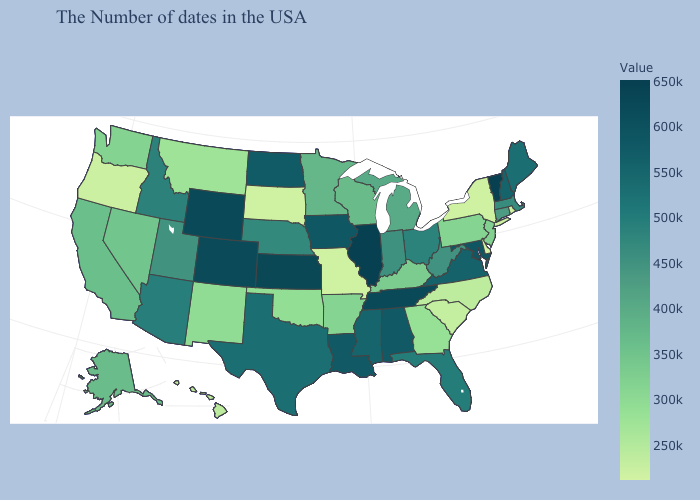Does Illinois have the highest value in the MidWest?
Give a very brief answer. Yes. Among the states that border Connecticut , does New York have the lowest value?
Concise answer only. Yes. Among the states that border Michigan , does Ohio have the highest value?
Concise answer only. Yes. Among the states that border Maryland , which have the lowest value?
Write a very short answer. Delaware. Does Maine have the highest value in the Northeast?
Be succinct. No. Does Washington have the highest value in the USA?
Write a very short answer. No. Does Delaware have the lowest value in the USA?
Short answer required. Yes. Does Missouri have the lowest value in the MidWest?
Concise answer only. Yes. Which states hav the highest value in the South?
Answer briefly. Tennessee. Does Minnesota have a lower value than Kentucky?
Quick response, please. No. 